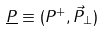Convert formula to latex. <formula><loc_0><loc_0><loc_500><loc_500>\underline { P } \equiv ( P ^ { + } , \vec { P } _ { \perp } )</formula> 